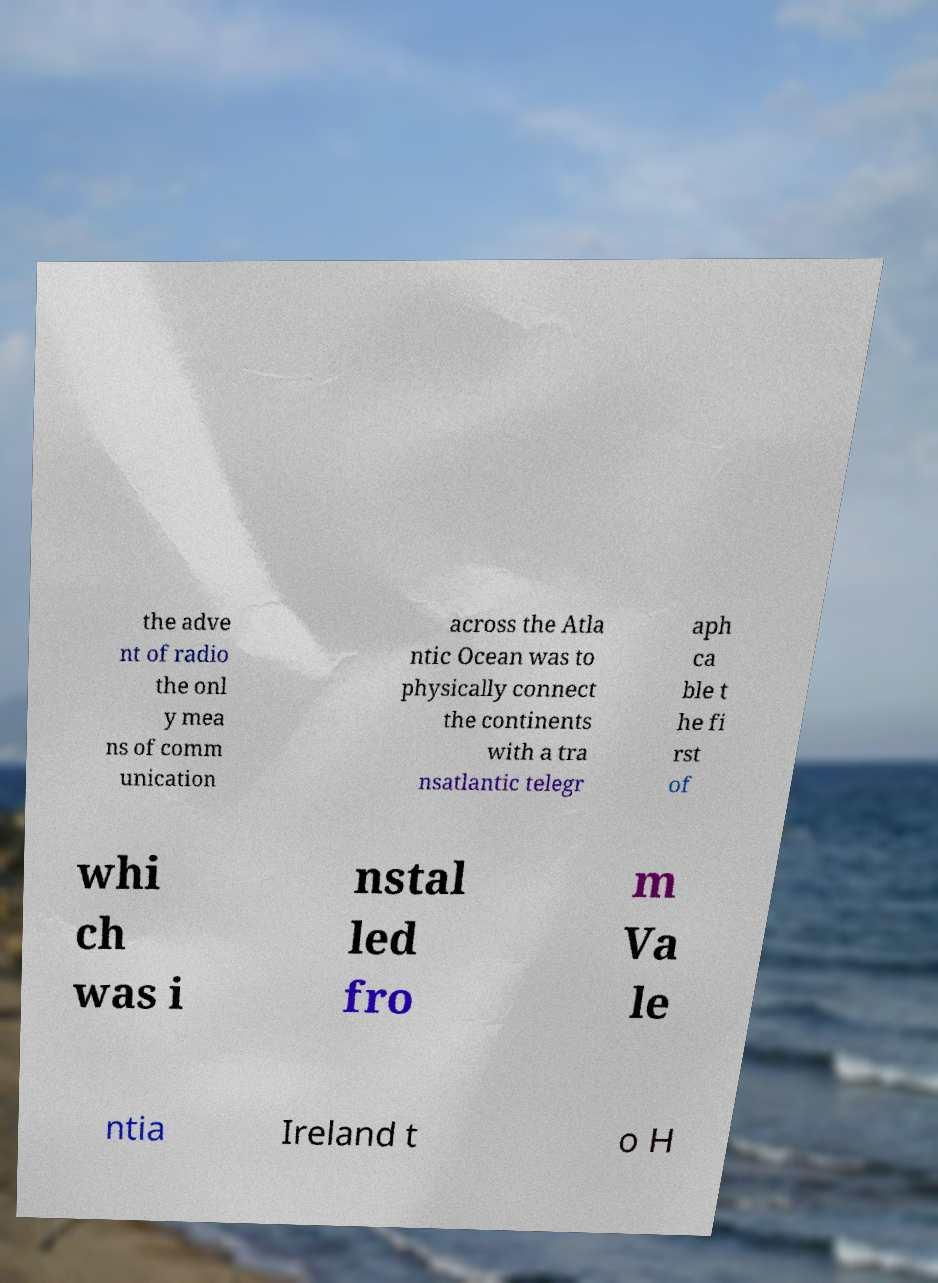Please identify and transcribe the text found in this image. the adve nt of radio the onl y mea ns of comm unication across the Atla ntic Ocean was to physically connect the continents with a tra nsatlantic telegr aph ca ble t he fi rst of whi ch was i nstal led fro m Va le ntia Ireland t o H 